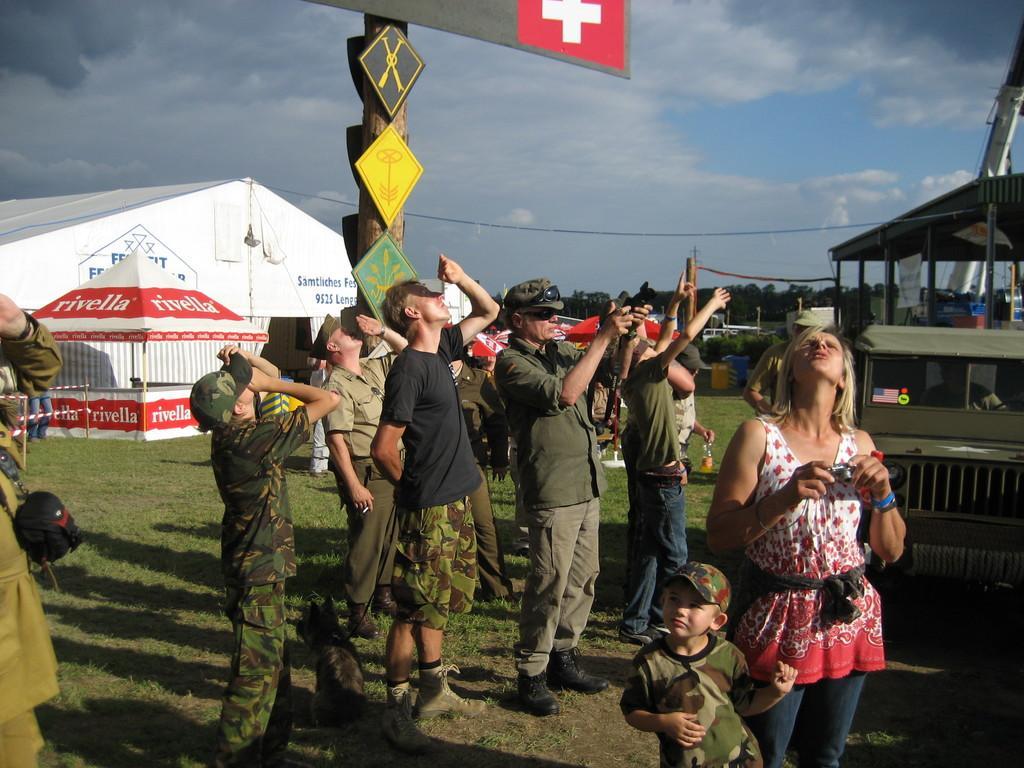Please provide a concise description of this image. In this image, we can see people and some are wearing uniforms and caps and some are holding objects in their hands. In the background, we can see sheds, trees, poles, boards, tents, some vehicles on the ground and at the top, there are clouds in the sky. 